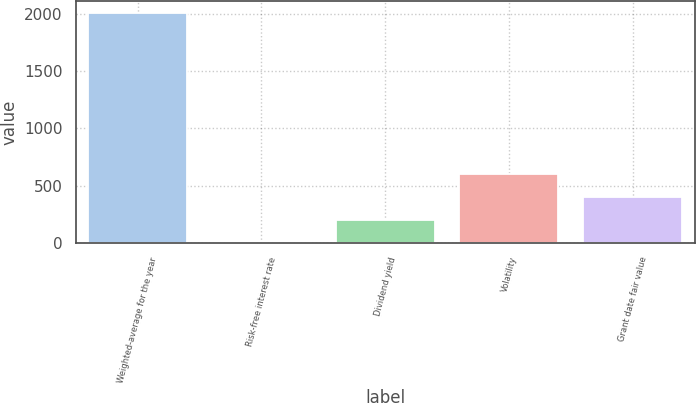<chart> <loc_0><loc_0><loc_500><loc_500><bar_chart><fcel>Weighted-average for the year<fcel>Risk-free interest rate<fcel>Dividend yield<fcel>Volatility<fcel>Grant date fair value<nl><fcel>2009<fcel>1.9<fcel>202.61<fcel>604.03<fcel>403.32<nl></chart> 